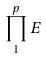<formula> <loc_0><loc_0><loc_500><loc_500>\prod _ { 1 } ^ { p } E</formula> 